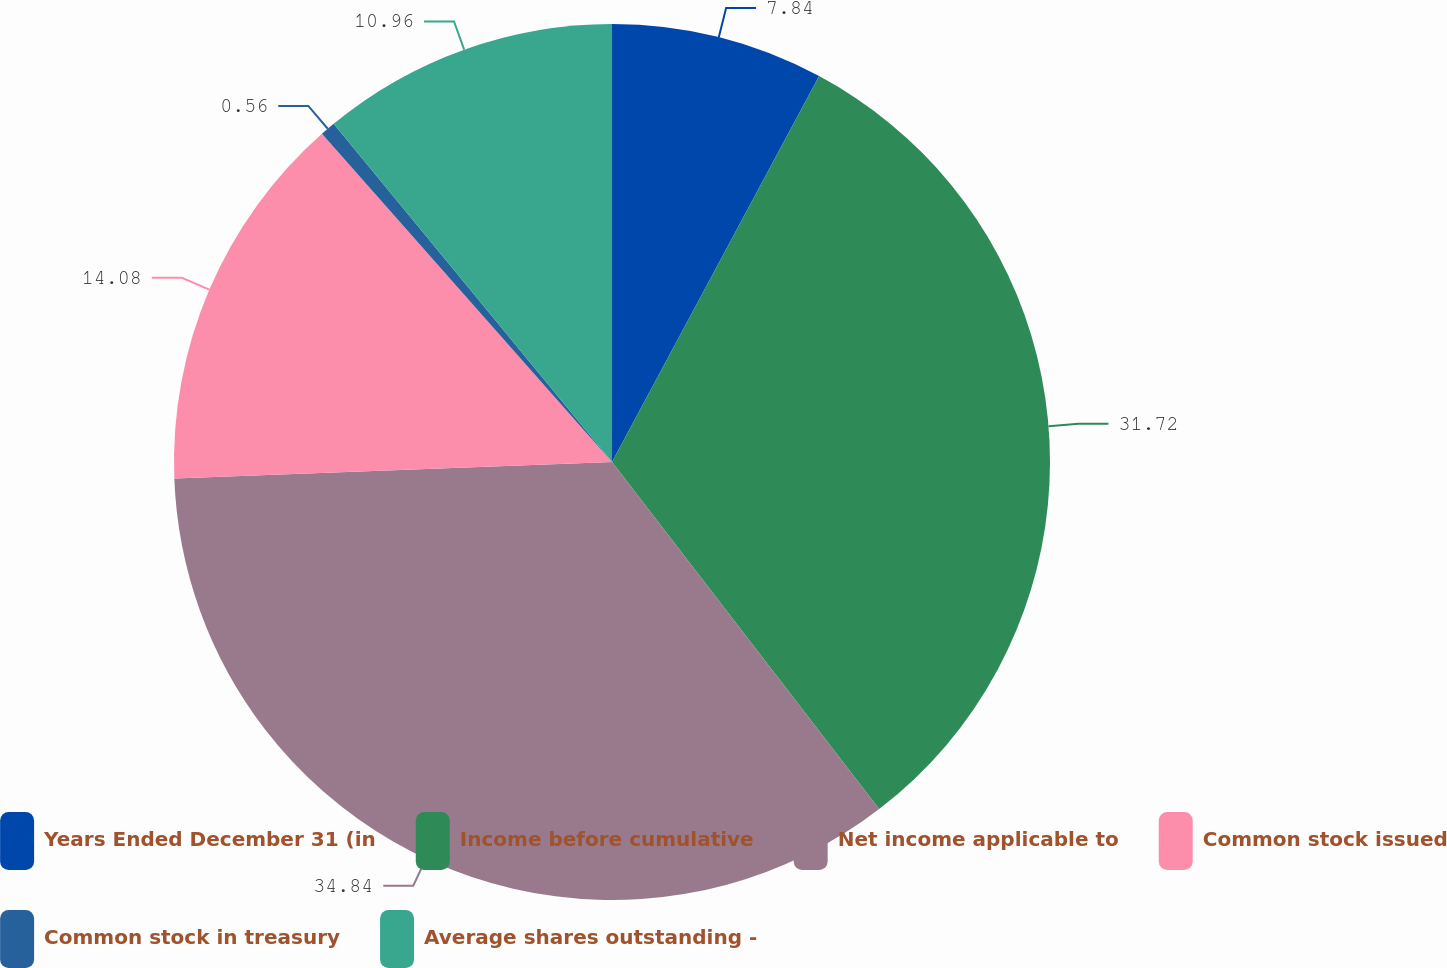Convert chart to OTSL. <chart><loc_0><loc_0><loc_500><loc_500><pie_chart><fcel>Years Ended December 31 (in<fcel>Income before cumulative<fcel>Net income applicable to<fcel>Common stock issued<fcel>Common stock in treasury<fcel>Average shares outstanding -<nl><fcel>7.84%<fcel>31.72%<fcel>34.84%<fcel>14.08%<fcel>0.56%<fcel>10.96%<nl></chart> 